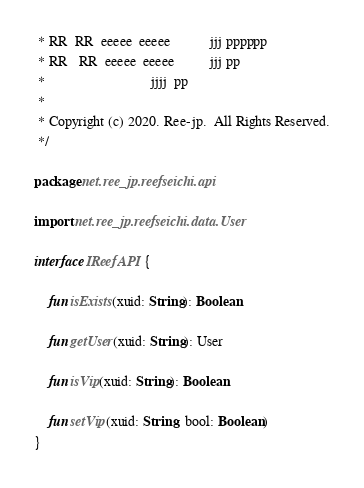Convert code to text. <code><loc_0><loc_0><loc_500><loc_500><_Kotlin_> * RR  RR  eeeee  eeeee           jjj pppppp
 * RR   RR  eeeee  eeeee          jjj pp
 *                              jjjj  pp
 *
 * Copyright (c) 2020. Ree-jp.  All Rights Reserved.
 */

package net.ree_jp.reefseichi.api

import net.ree_jp.reefseichi.data.User

interface IReefAPI {

    fun isExists(xuid: String): Boolean

    fun getUser(xuid: String): User

    fun isVip(xuid: String): Boolean

    fun setVip(xuid: String, bool: Boolean)
}</code> 